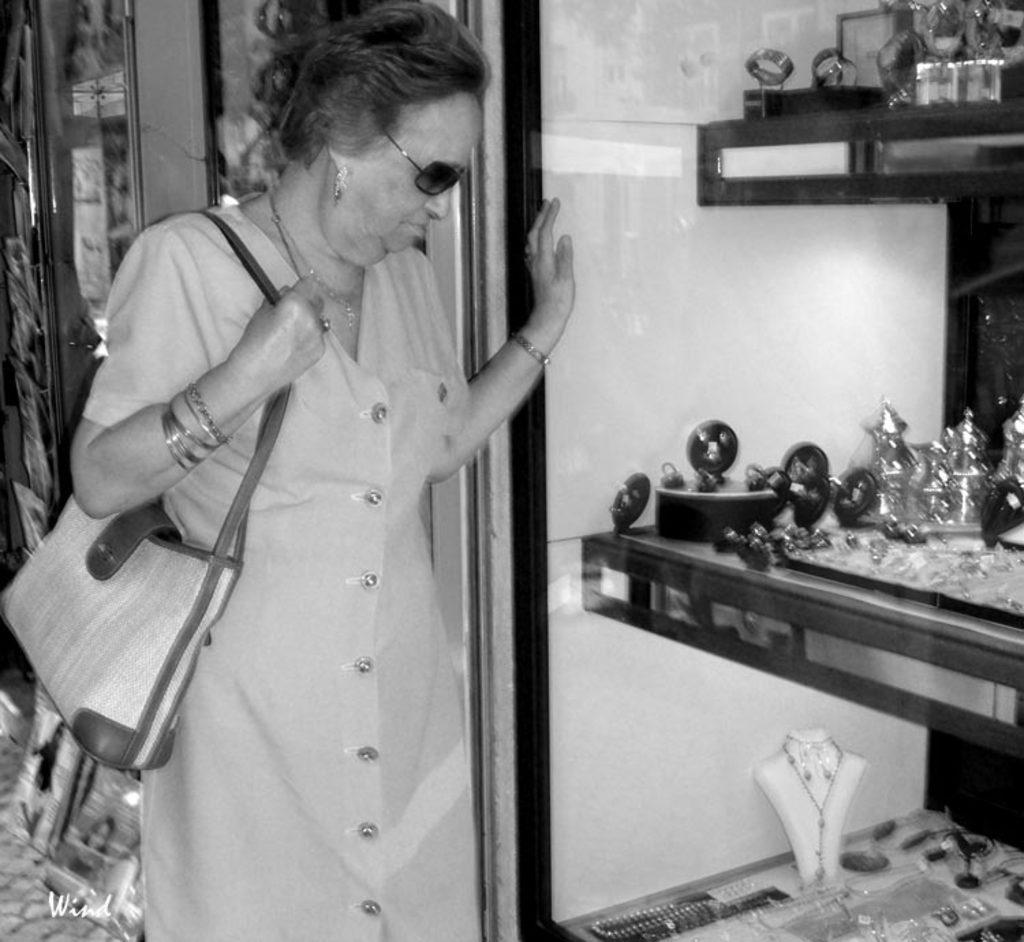Can you describe this image briefly? In this image I can see a woman is standing on the left side. I can see she is wearing bangles, and necklace, shades and I can also see she is carrying a bag. On the right side of this image I can see number of things on the shelves and in the front of them I can see a glass wall. I can also see this image is black and white in color and on the bottom left side of this image I can see a watermark. 